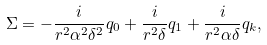Convert formula to latex. <formula><loc_0><loc_0><loc_500><loc_500>\Sigma = - \frac { i } { r ^ { 2 } \alpha ^ { 2 } \delta ^ { 2 } } q _ { 0 } + \frac { i } { r ^ { 2 } \delta } q _ { 1 } + \frac { i } { r ^ { 2 } \alpha \delta } q _ { k } ,</formula> 